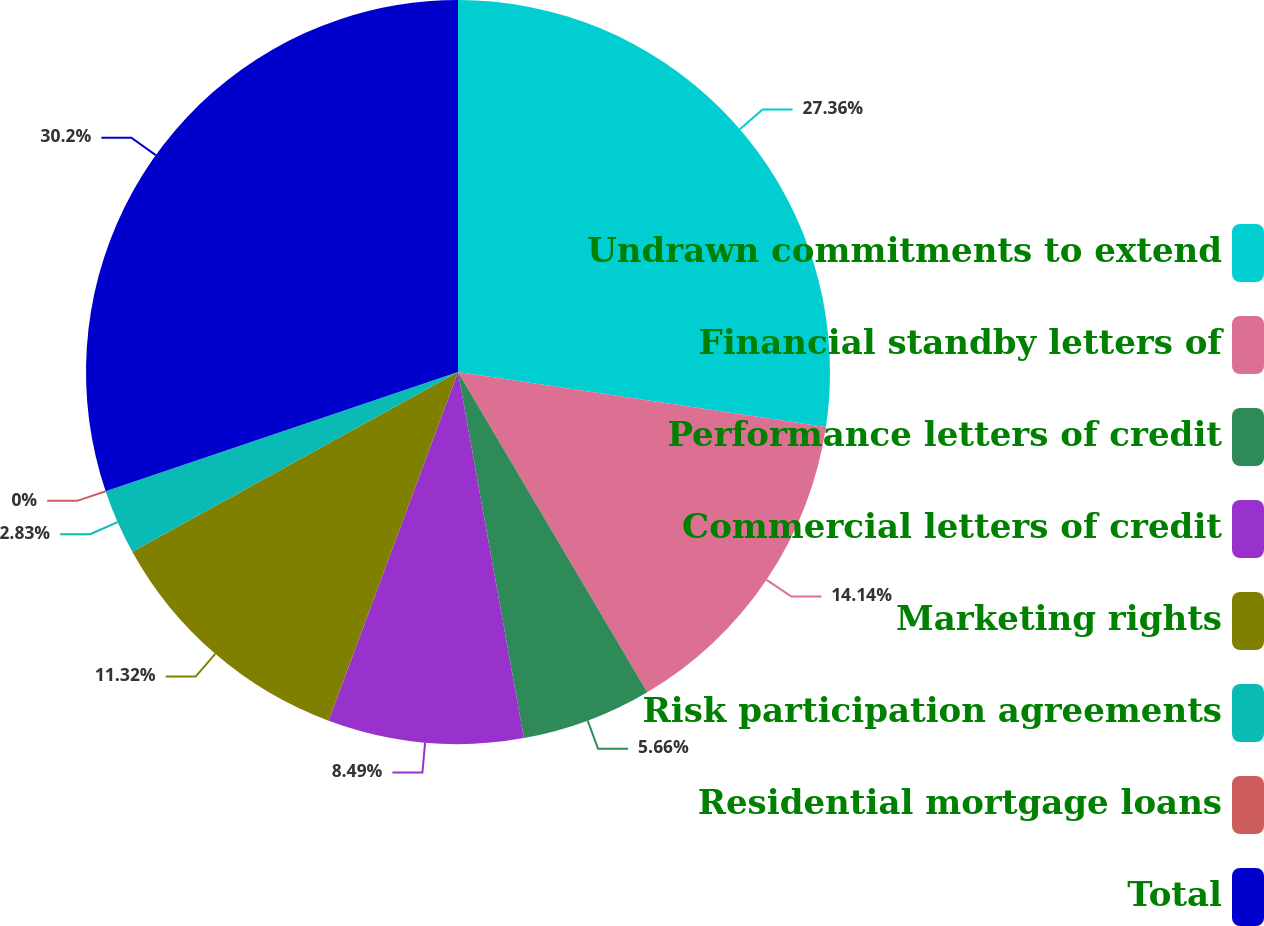<chart> <loc_0><loc_0><loc_500><loc_500><pie_chart><fcel>Undrawn commitments to extend<fcel>Financial standby letters of<fcel>Performance letters of credit<fcel>Commercial letters of credit<fcel>Marketing rights<fcel>Risk participation agreements<fcel>Residential mortgage loans<fcel>Total<nl><fcel>27.36%<fcel>14.14%<fcel>5.66%<fcel>8.49%<fcel>11.32%<fcel>2.83%<fcel>0.0%<fcel>30.19%<nl></chart> 